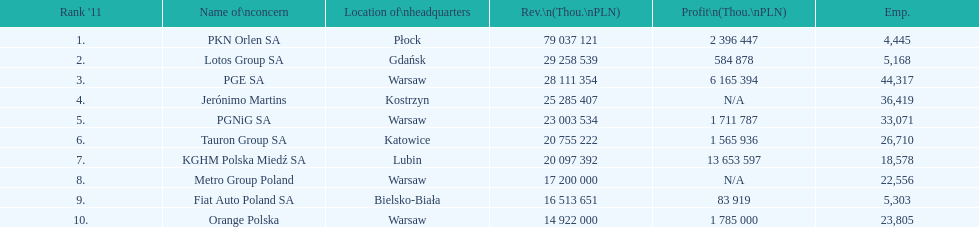Which company had the most revenue? PKN Orlen SA. 